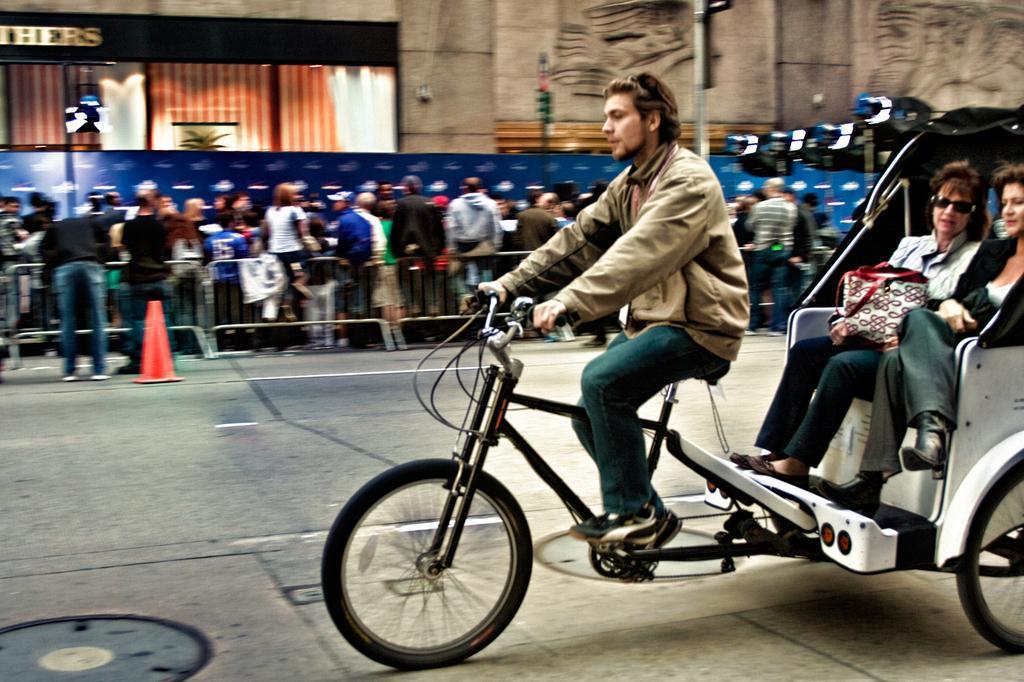Describe this image in one or two sentences. In this image I can see the person riding the vehicle and two people are sitting in it. In the background I can see the traffic cone, railing and the group of people with different color dresses. I can also see pole, banner and the building. 